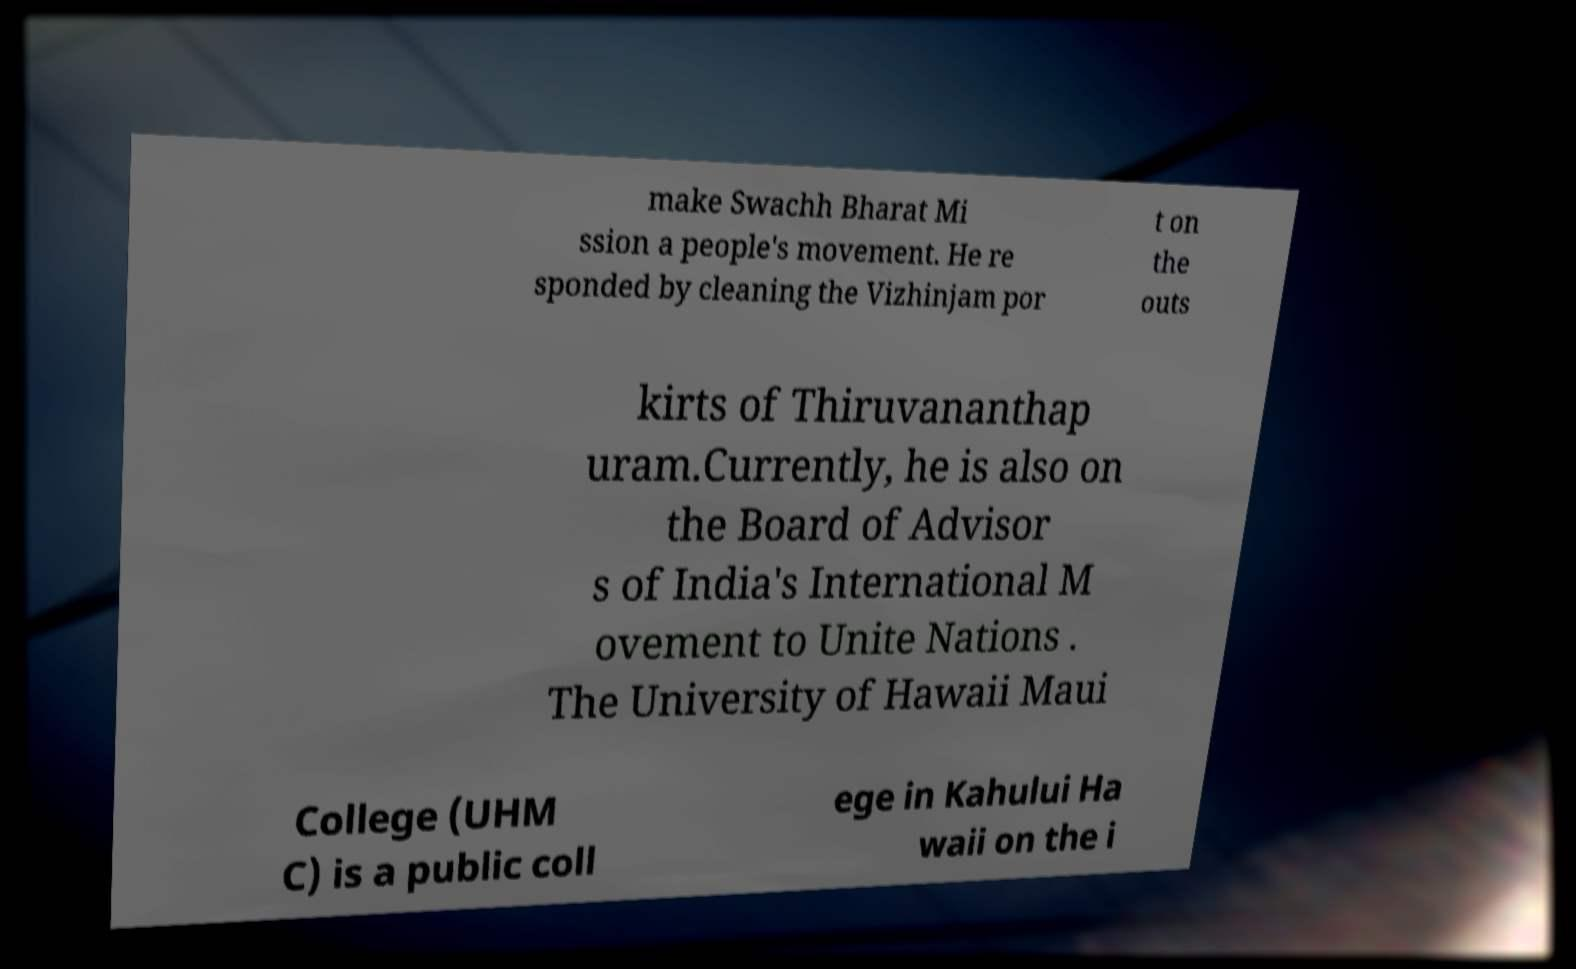What messages or text are displayed in this image? I need them in a readable, typed format. make Swachh Bharat Mi ssion a people's movement. He re sponded by cleaning the Vizhinjam por t on the outs kirts of Thiruvananthap uram.Currently, he is also on the Board of Advisor s of India's International M ovement to Unite Nations . The University of Hawaii Maui College (UHM C) is a public coll ege in Kahului Ha waii on the i 